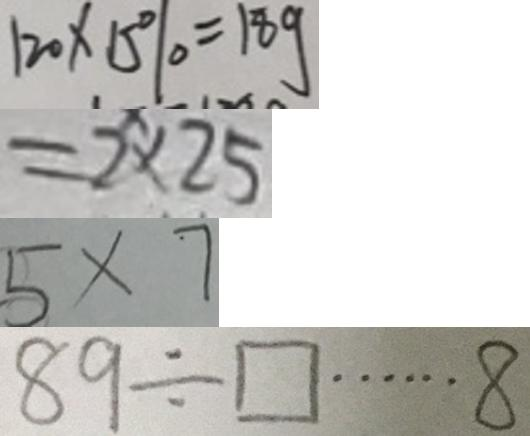<formula> <loc_0><loc_0><loc_500><loc_500>1 2 0 \times 1 5 \% = 1 8 g 
 = 2 \times 2 5 
 5 \times 7 
 8 9 \div \square \cdots 8</formula> 